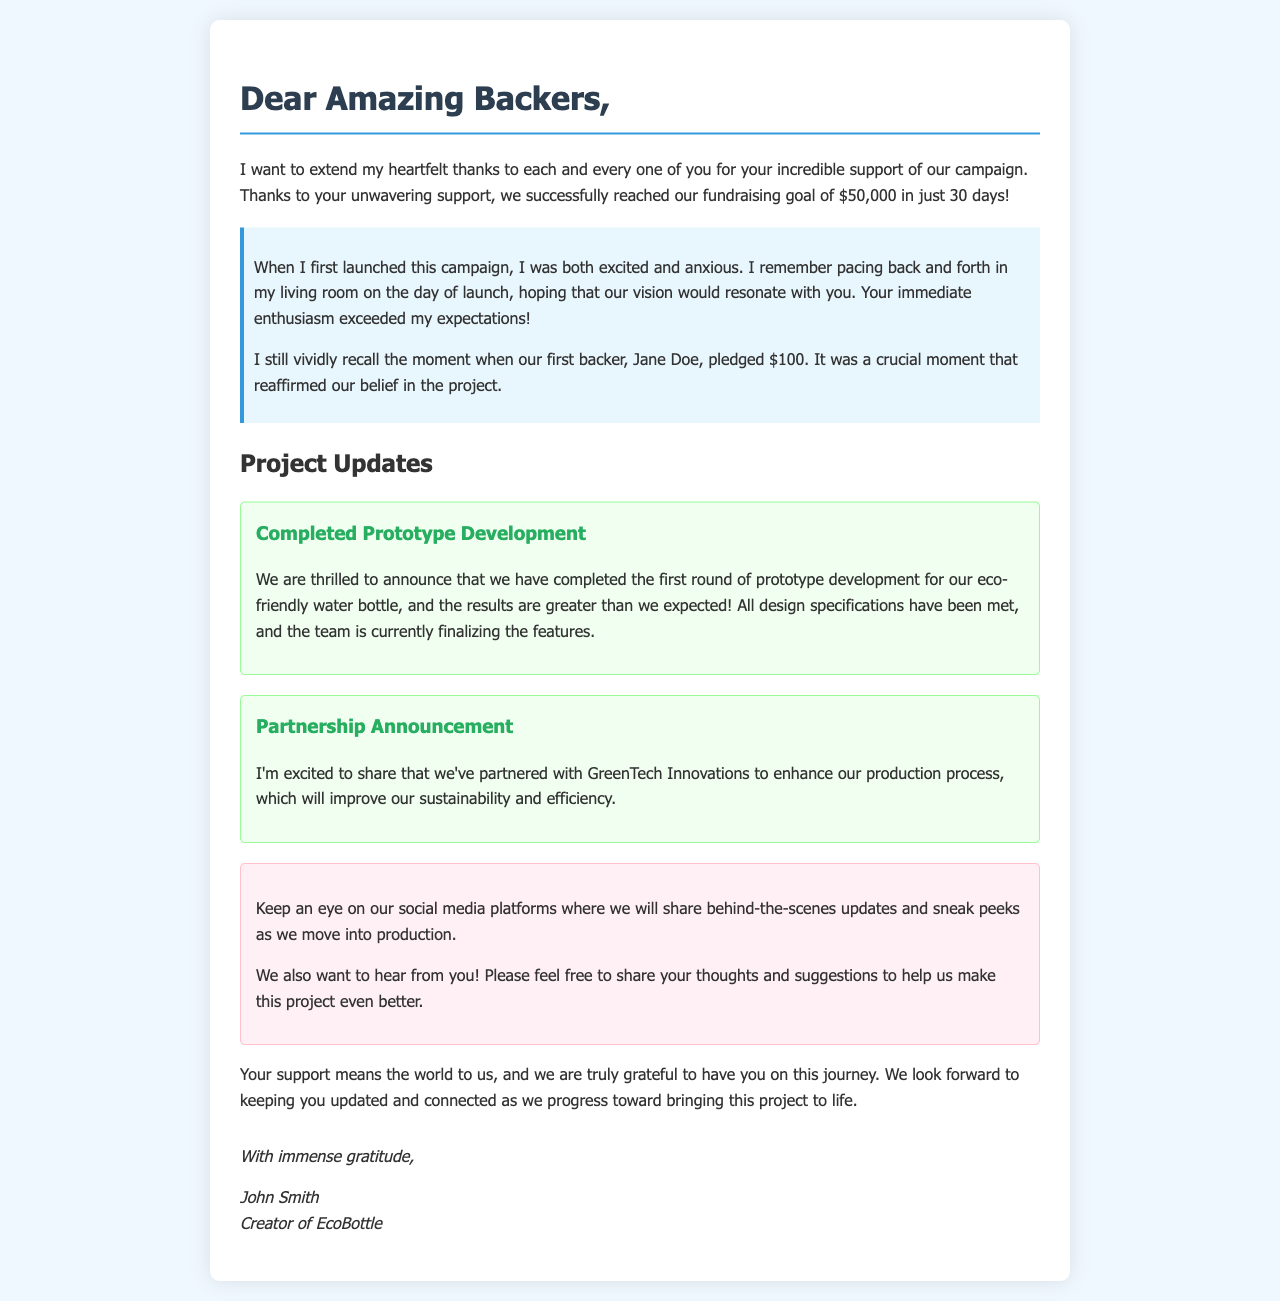What was the fundraising goal? The fundraising goal mentioned in the document is $50,000.
Answer: $50,000 Who was the first backer? The first backer mentioned in the document is Jane Doe.
Answer: Jane Doe How long did it take to reach the fundraising goal? The document states it took 30 days to reach the goal.
Answer: 30 days What milestone is celebrated regarding the prototype? The completed milestone for the prototype is "Completed Prototype Development."
Answer: Completed Prototype Development Which company is mentioned as a partner? The partner company announced in the document is GreenTech Innovations.
Answer: GreenTech Innovations What does the author encourage backers to do? The author encourages backers to share their thoughts and suggestions.
Answer: Share thoughts and suggestions What personal emotion does the author express at the start of the campaign? The author expresses feelings of excitement and anxiety at the start of the campaign.
Answer: Excitement and anxiety What is the author's name? The author's name is John Smith.
Answer: John Smith What type of updates will be shared on social media? The updates shared on social media will include behind-the-scenes information and sneak peeks.
Answer: Behind-the-scenes updates and sneak peeks 